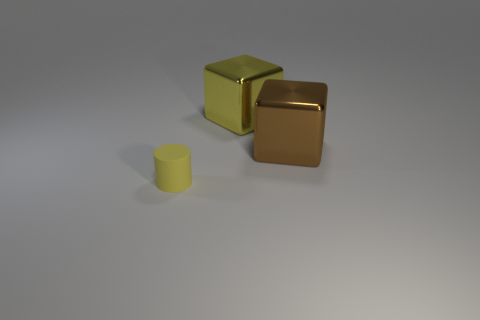Is there any other thing that has the same size as the cylinder?
Keep it short and to the point. No. Does the brown block have the same size as the yellow cylinder?
Your answer should be very brief. No. What material is the other object that is the same shape as the brown thing?
Keep it short and to the point. Metal. Is there any other thing that is the same material as the tiny object?
Give a very brief answer. No. What number of red things are either tiny things or blocks?
Keep it short and to the point. 0. There is a yellow object that is to the right of the cylinder; what is its material?
Provide a succinct answer. Metal. Is the number of big cubes greater than the number of tiny gray metallic objects?
Make the answer very short. Yes. There is a metal thing on the left side of the brown metallic object; is its shape the same as the brown thing?
Offer a terse response. Yes. What number of objects are in front of the brown metal thing and behind the rubber cylinder?
Keep it short and to the point. 0. What number of other small rubber objects are the same shape as the yellow rubber object?
Make the answer very short. 0. 